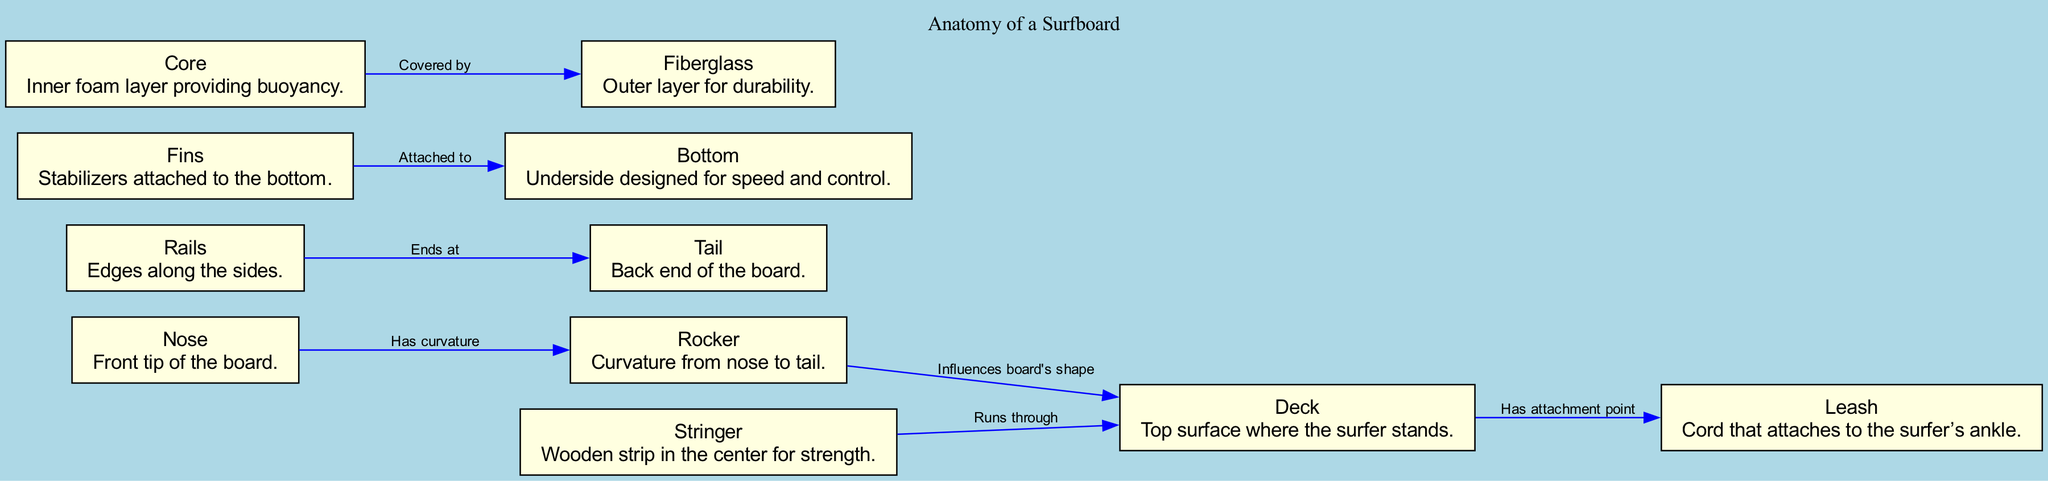what is the front tip of the board called? The diagram labels the front tip of the surfboard as the "Nose," which is identified in the node description.
Answer: Nose how many main components are listed in the diagram? The diagram lists a total of eleven components, as seen in the nodes section of the provided data.
Answer: Eleven what influence does the rocker have on the shape of the board? According to the edge connecting the "Rocker" and "Deck," the rocker "Influences board's shape," indicating its role in shaping the board's overall design.
Answer: Influences board's shape what are the edges along the sides of the board called? The diagram specifies that the edges along the sides of the surfboard are referred to as "Rails." This is directly mentioned in the node description.
Answer: Rails where does the stringer run through? The edge connecting the "Stringer" and "Deck" states that the stringer "Runs through" the deck, indicating its position in the surfboard's structure.
Answer: Runs through which component provides inner buoyancy? The diagram identifies the "Core" as the component that provides the inner foam layer, which is responsible for buoyancy. This is mentioned in the node description for the Core.
Answer: Core how does the leash connect to the surfboard? The edge connecting "Deck" and "Leash" shows that the leash "Has attachment point" on the deck, indicating how it connects to the surfer.
Answer: Has attachment point what is the purpose of fins in the surfboard? The diagram describes fins as "Stabilizers attached to the bottom," indicating their purpose in enhancing stability while surfing.
Answer: Stabilizers attached to the bottom what covers the core of the surfboard? The edge that connects "Core" and "Fiberglass" specifies that the core is "Covered by" the fiberglass, illustrating the protective outer layer.
Answer: Covered by what does the bottom of the board provide? The description for the "Bottom" states it is designed for "speed and control," highlighting its functional purpose.
Answer: Speed and control 